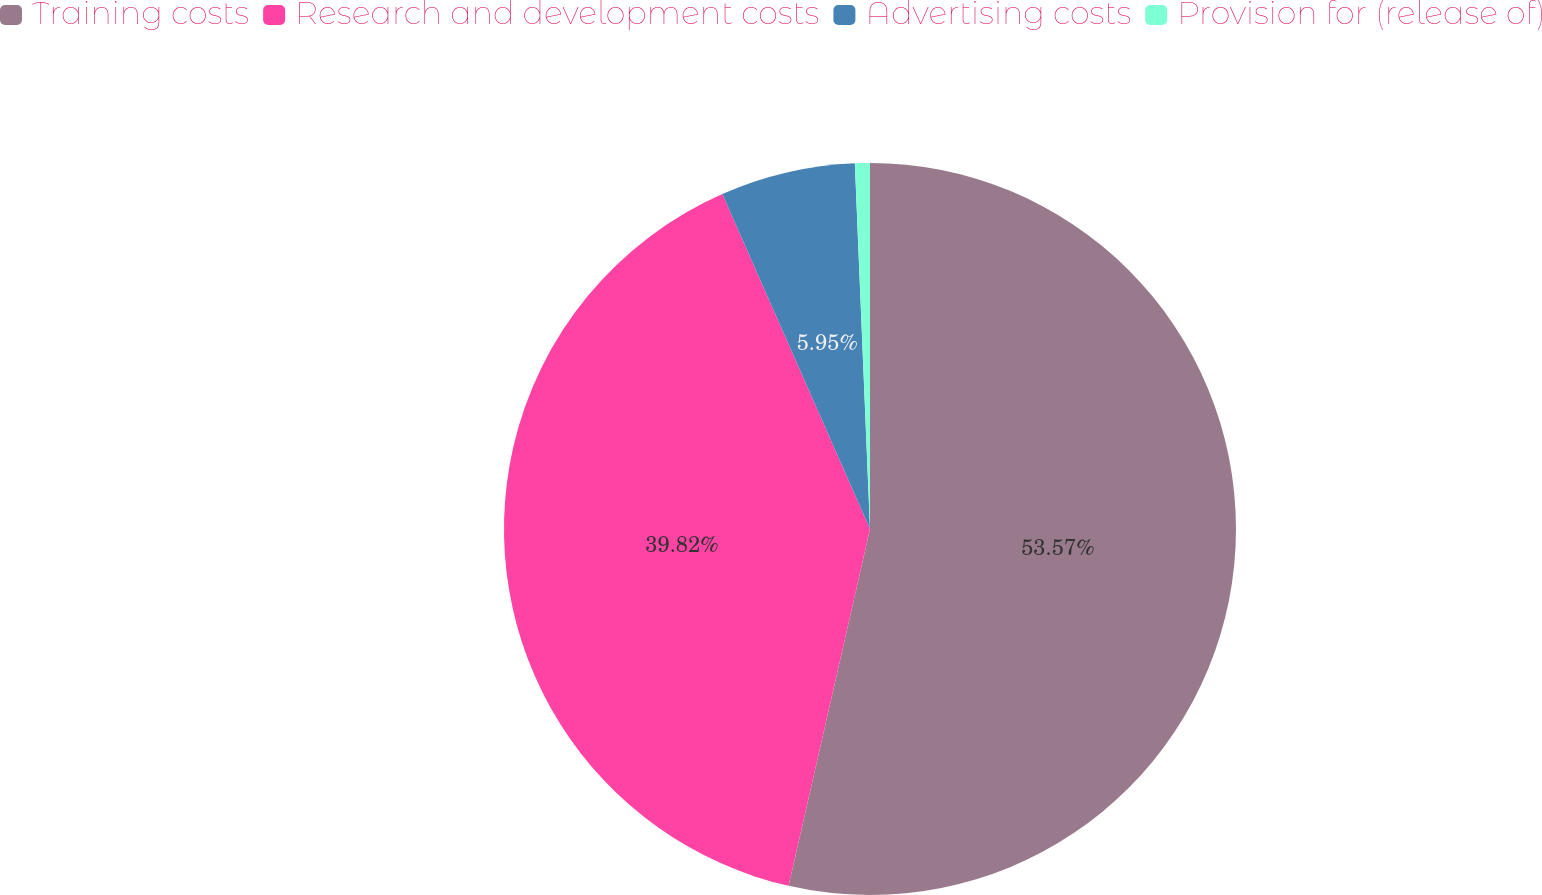Convert chart to OTSL. <chart><loc_0><loc_0><loc_500><loc_500><pie_chart><fcel>Training costs<fcel>Research and development costs<fcel>Advertising costs<fcel>Provision for (release of)<nl><fcel>53.57%<fcel>39.82%<fcel>5.95%<fcel>0.66%<nl></chart> 